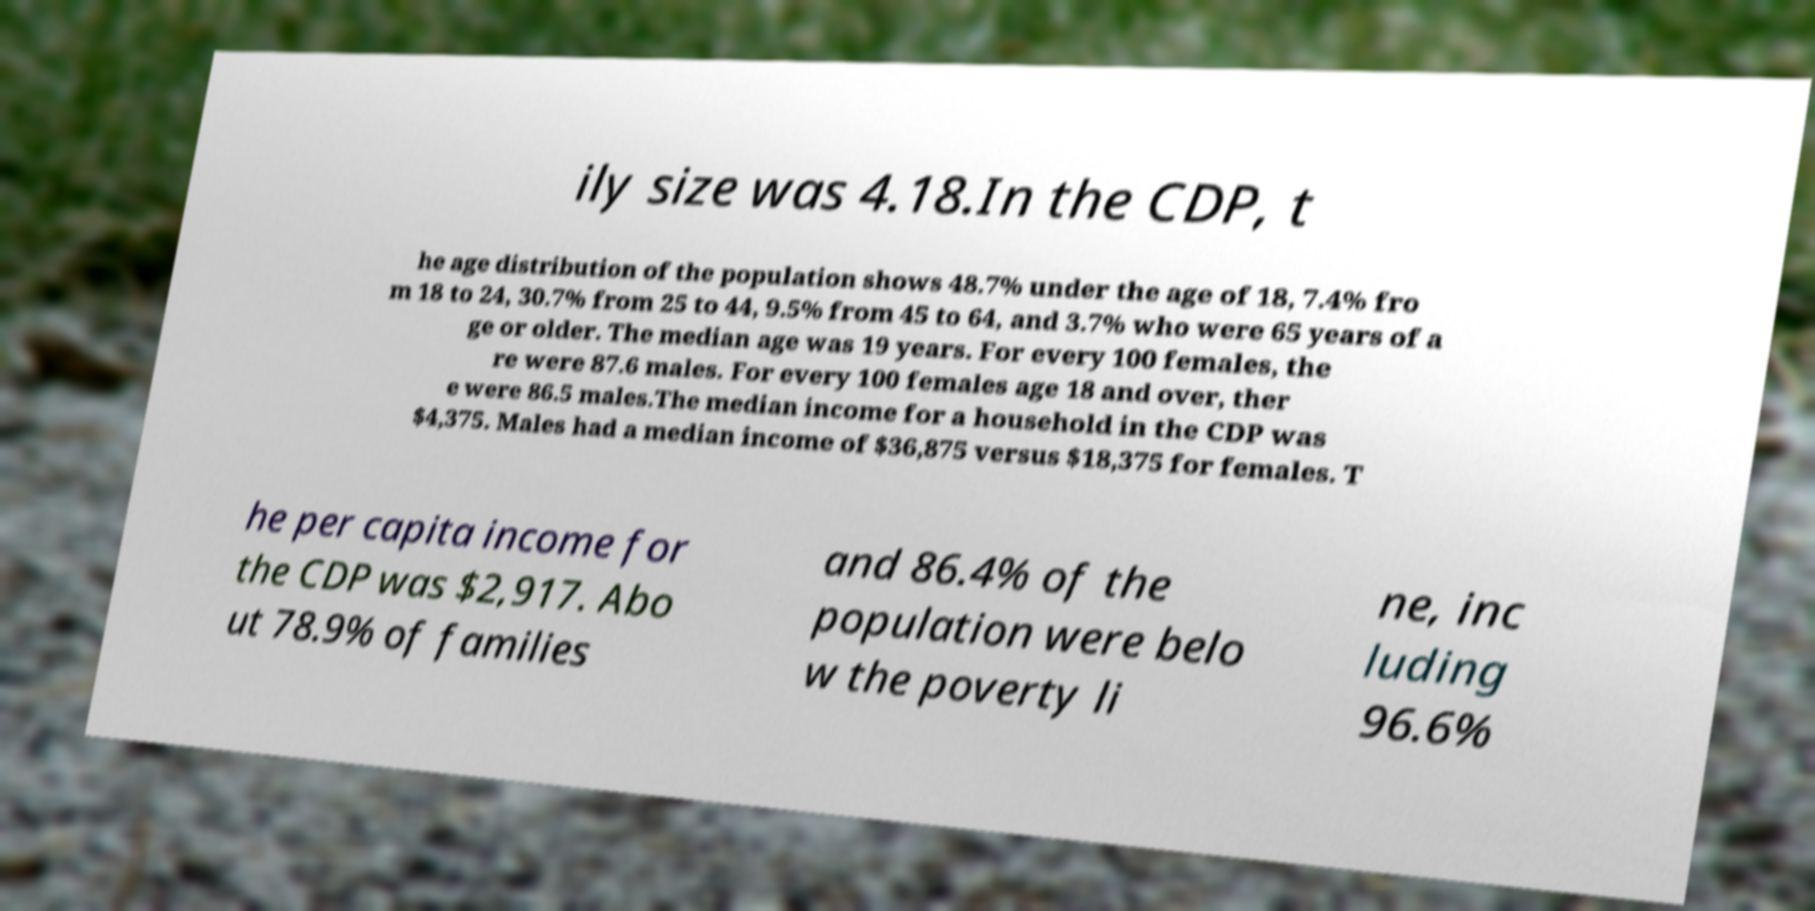Can you read and provide the text displayed in the image?This photo seems to have some interesting text. Can you extract and type it out for me? ily size was 4.18.In the CDP, t he age distribution of the population shows 48.7% under the age of 18, 7.4% fro m 18 to 24, 30.7% from 25 to 44, 9.5% from 45 to 64, and 3.7% who were 65 years of a ge or older. The median age was 19 years. For every 100 females, the re were 87.6 males. For every 100 females age 18 and over, ther e were 86.5 males.The median income for a household in the CDP was $4,375. Males had a median income of $36,875 versus $18,375 for females. T he per capita income for the CDP was $2,917. Abo ut 78.9% of families and 86.4% of the population were belo w the poverty li ne, inc luding 96.6% 